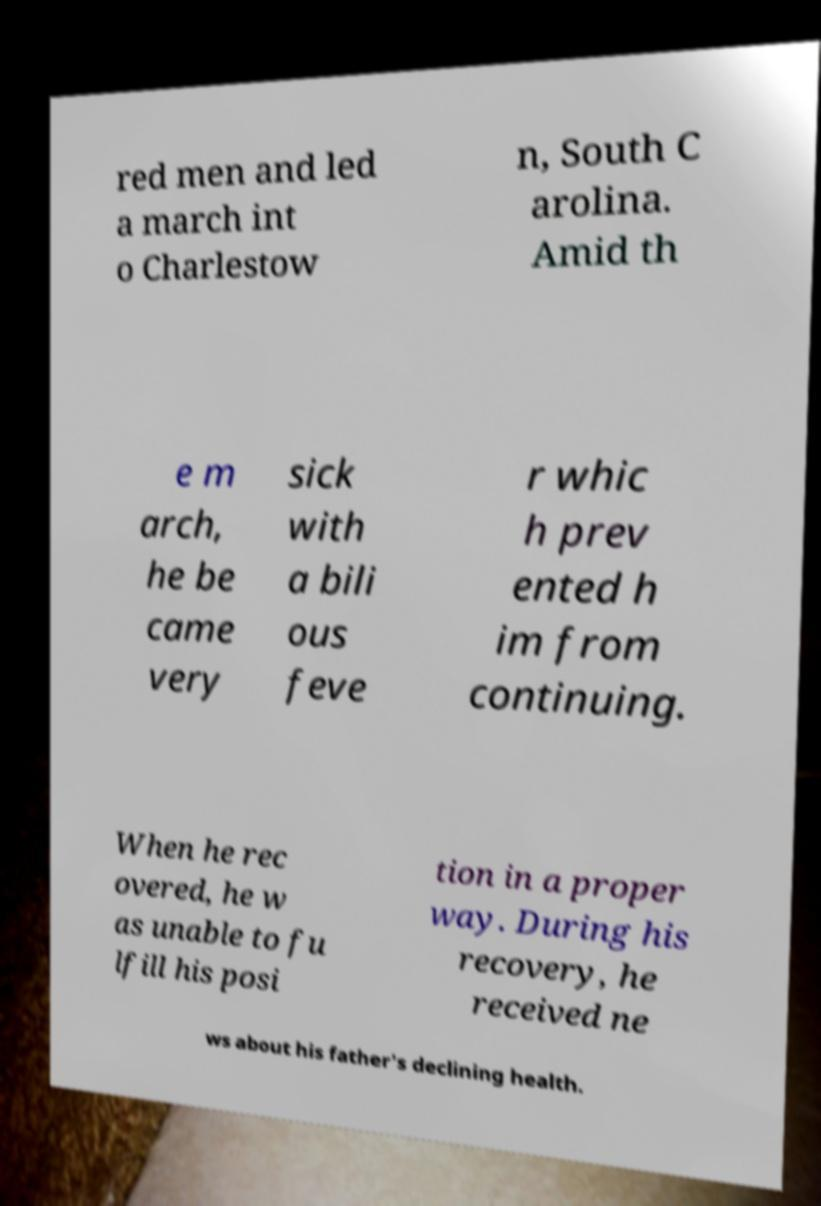I need the written content from this picture converted into text. Can you do that? red men and led a march int o Charlestow n, South C arolina. Amid th e m arch, he be came very sick with a bili ous feve r whic h prev ented h im from continuing. When he rec overed, he w as unable to fu lfill his posi tion in a proper way. During his recovery, he received ne ws about his father's declining health. 